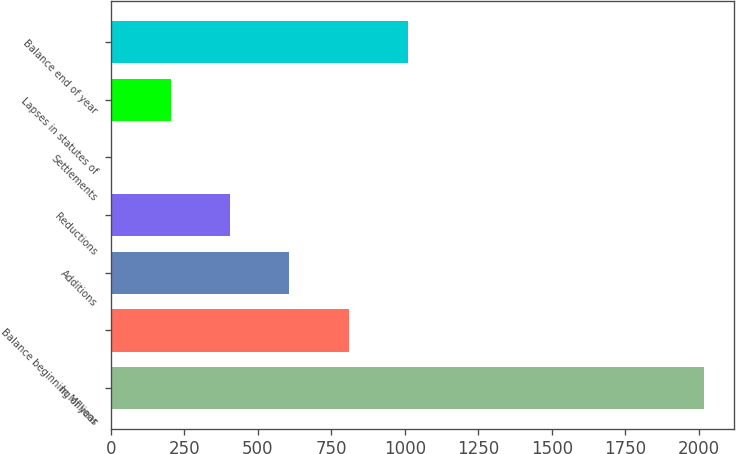<chart> <loc_0><loc_0><loc_500><loc_500><bar_chart><fcel>In Millions<fcel>Balance beginning of year<fcel>Additions<fcel>Reductions<fcel>Settlements<fcel>Lapses in statutes of<fcel>Balance end of year<nl><fcel>2018<fcel>809.54<fcel>608.13<fcel>406.72<fcel>3.9<fcel>205.31<fcel>1010.95<nl></chart> 